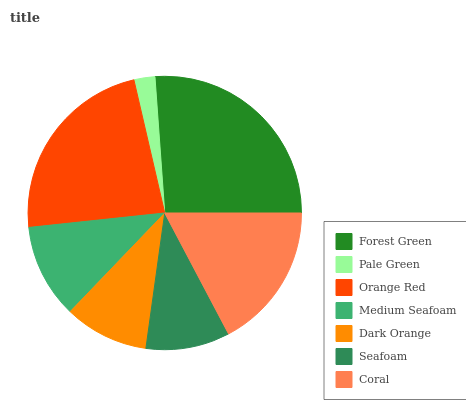Is Pale Green the minimum?
Answer yes or no. Yes. Is Forest Green the maximum?
Answer yes or no. Yes. Is Orange Red the minimum?
Answer yes or no. No. Is Orange Red the maximum?
Answer yes or no. No. Is Orange Red greater than Pale Green?
Answer yes or no. Yes. Is Pale Green less than Orange Red?
Answer yes or no. Yes. Is Pale Green greater than Orange Red?
Answer yes or no. No. Is Orange Red less than Pale Green?
Answer yes or no. No. Is Medium Seafoam the high median?
Answer yes or no. Yes. Is Medium Seafoam the low median?
Answer yes or no. Yes. Is Pale Green the high median?
Answer yes or no. No. Is Coral the low median?
Answer yes or no. No. 